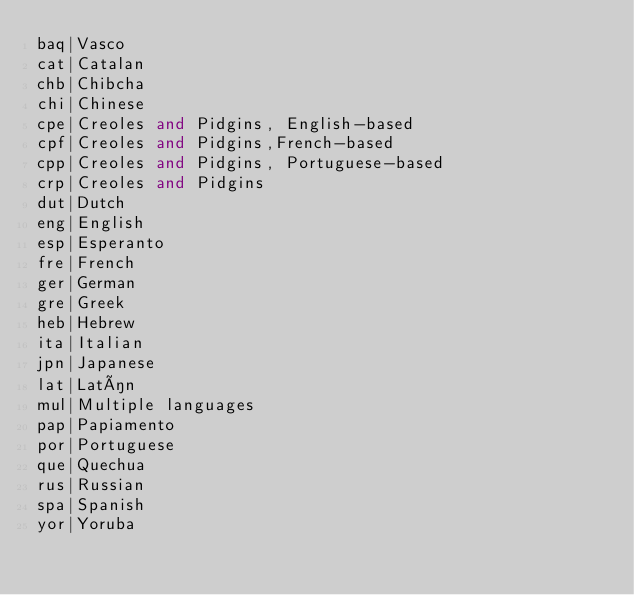<code> <loc_0><loc_0><loc_500><loc_500><_SQL_>baq|Vasco
cat|Catalan
chb|Chibcha
chi|Chinese
cpe|Creoles and Pidgins, English-based
cpf|Creoles and Pidgins,French-based
cpp|Creoles and Pidgins, Portuguese-based
crp|Creoles and Pidgins
dut|Dutch
eng|English
esp|Esperanto
fre|French
ger|German
gre|Greek
heb|Hebrew
ita|Italian
jpn|Japanese
lat|Latín
mul|Multiple languages
pap|Papiamento
por|Portuguese
que|Quechua
rus|Russian
spa|Spanish
yor|Yoruba
</code> 